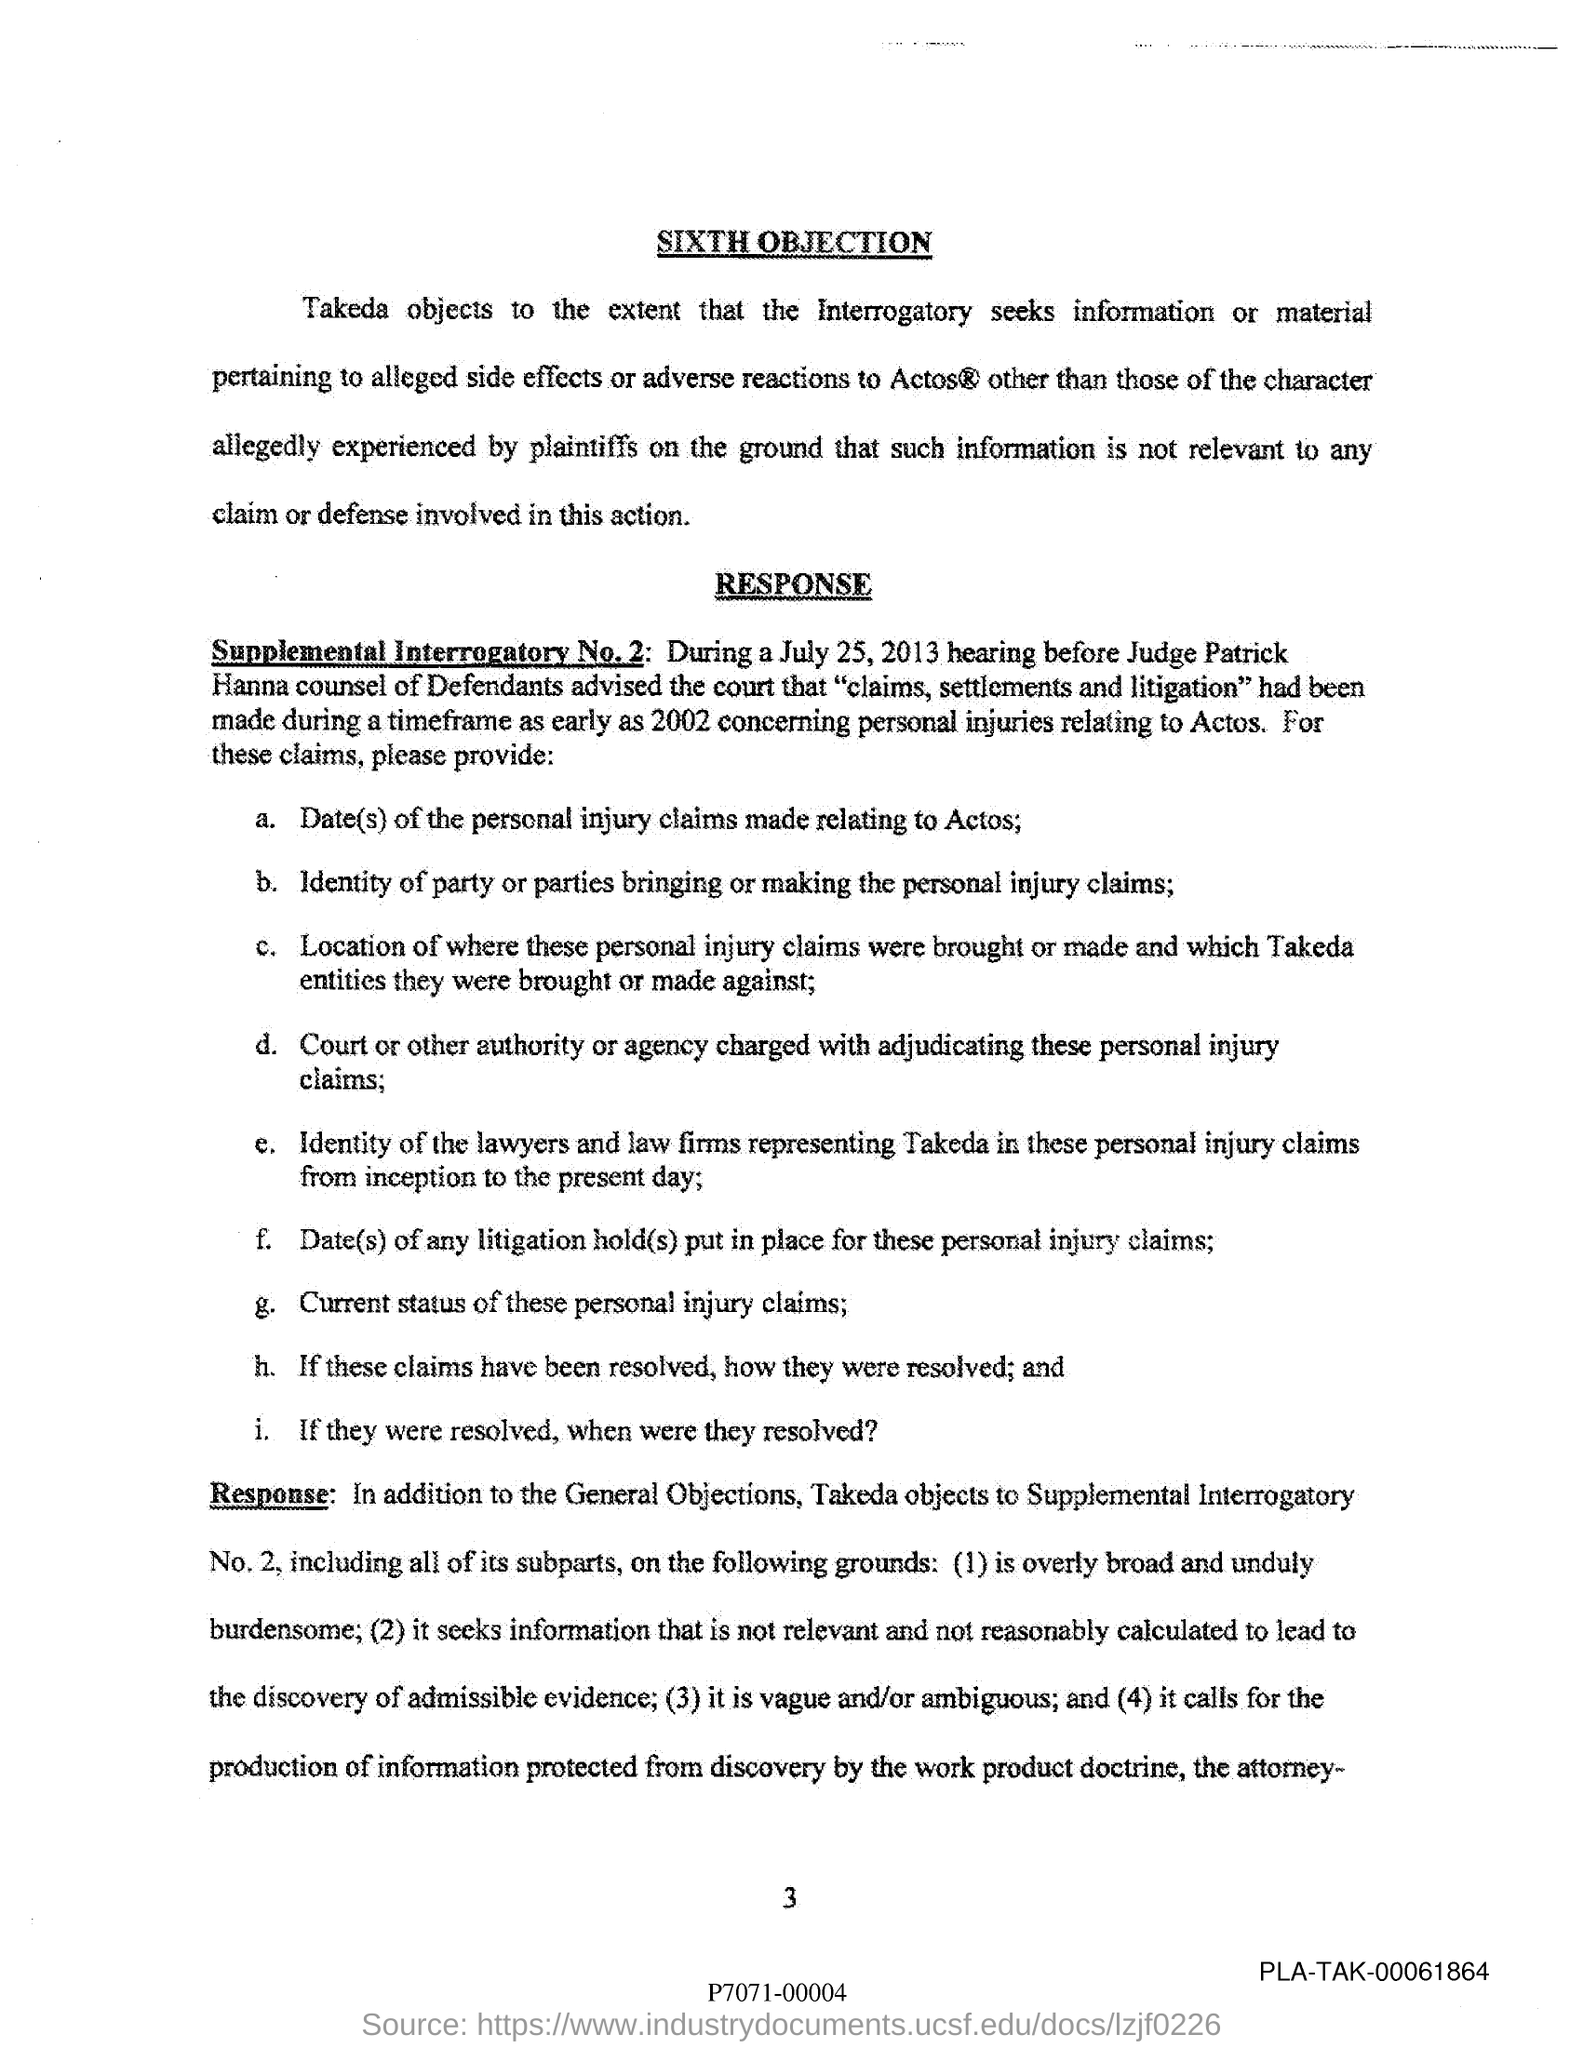Heading of the first paragraph?
Offer a terse response. SIXTH OBJECTION. Name of the judge?
Ensure brevity in your answer.  Patrick Hanna. What is the page no mentioned in this document?
Offer a terse response. 3. When was the hearing before Judge?
Your answer should be compact. July 25, 2013. 